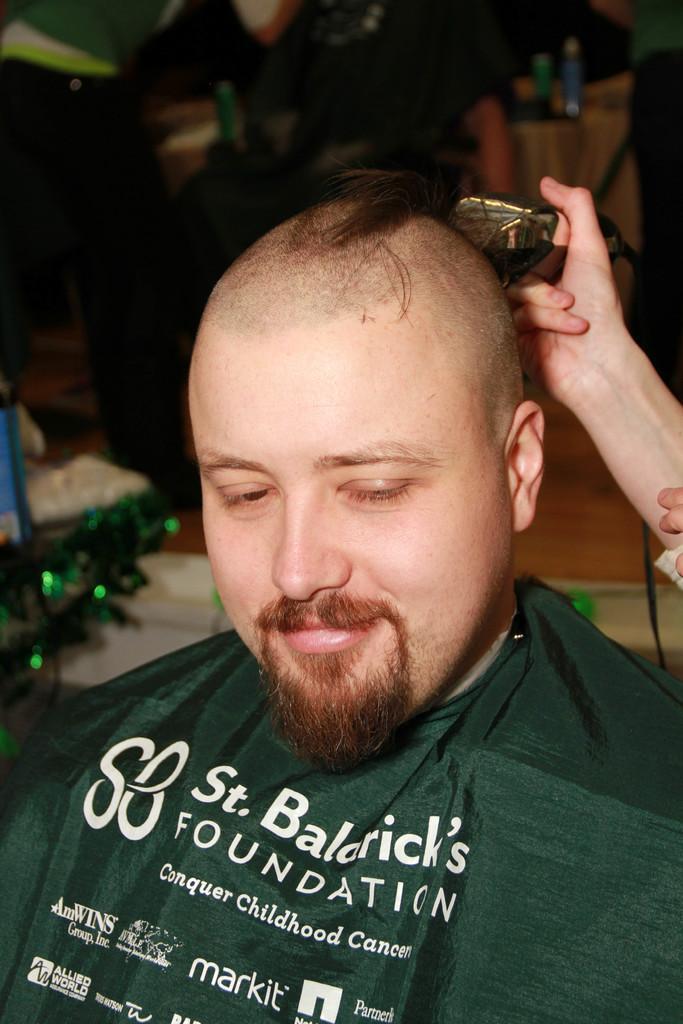Describe this image in one or two sentences. This person is smiling. Another person is holding a trimmer. Background it is blur. We can see bottles and people. 